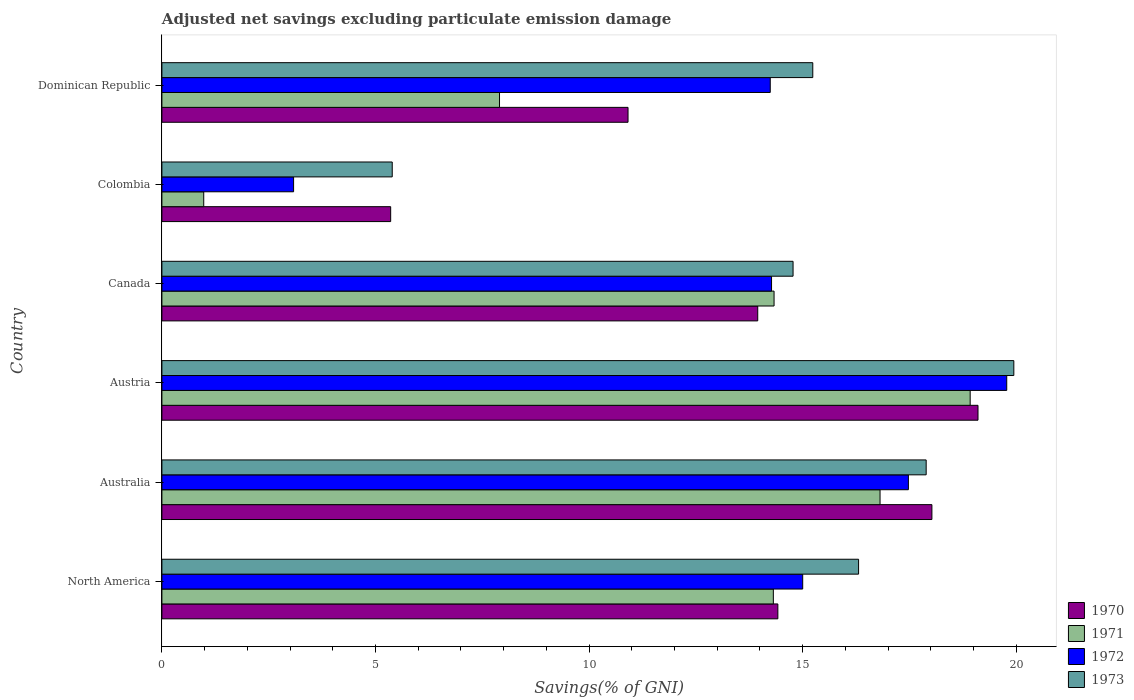How many different coloured bars are there?
Your response must be concise. 4. Are the number of bars on each tick of the Y-axis equal?
Provide a succinct answer. Yes. How many bars are there on the 4th tick from the bottom?
Your response must be concise. 4. What is the label of the 5th group of bars from the top?
Give a very brief answer. Australia. What is the adjusted net savings in 1972 in Canada?
Provide a short and direct response. 14.27. Across all countries, what is the maximum adjusted net savings in 1973?
Offer a very short reply. 19.94. Across all countries, what is the minimum adjusted net savings in 1971?
Offer a very short reply. 0.98. In which country was the adjusted net savings in 1970 maximum?
Ensure brevity in your answer.  Austria. In which country was the adjusted net savings in 1973 minimum?
Keep it short and to the point. Colombia. What is the total adjusted net savings in 1972 in the graph?
Your response must be concise. 83.85. What is the difference between the adjusted net savings in 1971 in Australia and that in Colombia?
Your response must be concise. 15.83. What is the difference between the adjusted net savings in 1971 in North America and the adjusted net savings in 1970 in Canada?
Provide a succinct answer. 0.37. What is the average adjusted net savings in 1971 per country?
Provide a short and direct response. 12.21. What is the difference between the adjusted net savings in 1970 and adjusted net savings in 1973 in Canada?
Offer a terse response. -0.83. What is the ratio of the adjusted net savings in 1970 in Austria to that in North America?
Make the answer very short. 1.32. What is the difference between the highest and the second highest adjusted net savings in 1971?
Offer a terse response. 2.11. What is the difference between the highest and the lowest adjusted net savings in 1972?
Ensure brevity in your answer.  16.7. In how many countries, is the adjusted net savings in 1970 greater than the average adjusted net savings in 1970 taken over all countries?
Your answer should be compact. 4. Is the sum of the adjusted net savings in 1971 in Australia and Canada greater than the maximum adjusted net savings in 1973 across all countries?
Provide a succinct answer. Yes. Is it the case that in every country, the sum of the adjusted net savings in 1973 and adjusted net savings in 1972 is greater than the sum of adjusted net savings in 1971 and adjusted net savings in 1970?
Provide a succinct answer. No. What does the 3rd bar from the top in North America represents?
Your answer should be compact. 1971. How many bars are there?
Your answer should be compact. 24. Are all the bars in the graph horizontal?
Give a very brief answer. Yes. How many countries are there in the graph?
Keep it short and to the point. 6. What is the difference between two consecutive major ticks on the X-axis?
Keep it short and to the point. 5. Does the graph contain any zero values?
Offer a terse response. No. How many legend labels are there?
Give a very brief answer. 4. What is the title of the graph?
Provide a succinct answer. Adjusted net savings excluding particulate emission damage. Does "1991" appear as one of the legend labels in the graph?
Give a very brief answer. No. What is the label or title of the X-axis?
Your answer should be very brief. Savings(% of GNI). What is the label or title of the Y-axis?
Provide a short and direct response. Country. What is the Savings(% of GNI) of 1970 in North America?
Keep it short and to the point. 14.42. What is the Savings(% of GNI) of 1971 in North America?
Your answer should be compact. 14.31. What is the Savings(% of GNI) of 1972 in North America?
Make the answer very short. 15. What is the Savings(% of GNI) of 1973 in North America?
Provide a succinct answer. 16.31. What is the Savings(% of GNI) in 1970 in Australia?
Your answer should be very brief. 18.03. What is the Savings(% of GNI) of 1971 in Australia?
Ensure brevity in your answer.  16.81. What is the Savings(% of GNI) of 1972 in Australia?
Provide a short and direct response. 17.48. What is the Savings(% of GNI) of 1973 in Australia?
Ensure brevity in your answer.  17.89. What is the Savings(% of GNI) in 1970 in Austria?
Give a very brief answer. 19.11. What is the Savings(% of GNI) in 1971 in Austria?
Make the answer very short. 18.92. What is the Savings(% of GNI) in 1972 in Austria?
Offer a terse response. 19.78. What is the Savings(% of GNI) of 1973 in Austria?
Provide a short and direct response. 19.94. What is the Savings(% of GNI) in 1970 in Canada?
Your answer should be very brief. 13.95. What is the Savings(% of GNI) in 1971 in Canada?
Keep it short and to the point. 14.33. What is the Savings(% of GNI) of 1972 in Canada?
Your response must be concise. 14.27. What is the Savings(% of GNI) in 1973 in Canada?
Keep it short and to the point. 14.78. What is the Savings(% of GNI) in 1970 in Colombia?
Your response must be concise. 5.36. What is the Savings(% of GNI) in 1971 in Colombia?
Your answer should be compact. 0.98. What is the Savings(% of GNI) in 1972 in Colombia?
Ensure brevity in your answer.  3.08. What is the Savings(% of GNI) of 1973 in Colombia?
Provide a succinct answer. 5.39. What is the Savings(% of GNI) of 1970 in Dominican Republic?
Your response must be concise. 10.91. What is the Savings(% of GNI) of 1971 in Dominican Republic?
Offer a very short reply. 7.9. What is the Savings(% of GNI) in 1972 in Dominican Republic?
Offer a very short reply. 14.24. What is the Savings(% of GNI) of 1973 in Dominican Republic?
Provide a short and direct response. 15.24. Across all countries, what is the maximum Savings(% of GNI) of 1970?
Provide a short and direct response. 19.11. Across all countries, what is the maximum Savings(% of GNI) of 1971?
Ensure brevity in your answer.  18.92. Across all countries, what is the maximum Savings(% of GNI) in 1972?
Make the answer very short. 19.78. Across all countries, what is the maximum Savings(% of GNI) in 1973?
Ensure brevity in your answer.  19.94. Across all countries, what is the minimum Savings(% of GNI) in 1970?
Your answer should be compact. 5.36. Across all countries, what is the minimum Savings(% of GNI) of 1971?
Give a very brief answer. 0.98. Across all countries, what is the minimum Savings(% of GNI) in 1972?
Give a very brief answer. 3.08. Across all countries, what is the minimum Savings(% of GNI) in 1973?
Your answer should be very brief. 5.39. What is the total Savings(% of GNI) of 1970 in the graph?
Provide a short and direct response. 81.77. What is the total Savings(% of GNI) of 1971 in the graph?
Make the answer very short. 73.26. What is the total Savings(% of GNI) of 1972 in the graph?
Provide a short and direct response. 83.85. What is the total Savings(% of GNI) of 1973 in the graph?
Your answer should be compact. 89.55. What is the difference between the Savings(% of GNI) in 1970 in North America and that in Australia?
Your answer should be very brief. -3.61. What is the difference between the Savings(% of GNI) of 1971 in North America and that in Australia?
Offer a terse response. -2.5. What is the difference between the Savings(% of GNI) of 1972 in North America and that in Australia?
Make the answer very short. -2.47. What is the difference between the Savings(% of GNI) in 1973 in North America and that in Australia?
Provide a short and direct response. -1.58. What is the difference between the Savings(% of GNI) in 1970 in North America and that in Austria?
Give a very brief answer. -4.69. What is the difference between the Savings(% of GNI) in 1971 in North America and that in Austria?
Your answer should be compact. -4.61. What is the difference between the Savings(% of GNI) of 1972 in North America and that in Austria?
Offer a very short reply. -4.78. What is the difference between the Savings(% of GNI) in 1973 in North America and that in Austria?
Your response must be concise. -3.63. What is the difference between the Savings(% of GNI) of 1970 in North America and that in Canada?
Your response must be concise. 0.47. What is the difference between the Savings(% of GNI) of 1971 in North America and that in Canada?
Your answer should be very brief. -0.02. What is the difference between the Savings(% of GNI) of 1972 in North America and that in Canada?
Keep it short and to the point. 0.73. What is the difference between the Savings(% of GNI) in 1973 in North America and that in Canada?
Ensure brevity in your answer.  1.53. What is the difference between the Savings(% of GNI) of 1970 in North America and that in Colombia?
Provide a short and direct response. 9.06. What is the difference between the Savings(% of GNI) in 1971 in North America and that in Colombia?
Make the answer very short. 13.34. What is the difference between the Savings(% of GNI) of 1972 in North America and that in Colombia?
Offer a terse response. 11.92. What is the difference between the Savings(% of GNI) of 1973 in North America and that in Colombia?
Your answer should be compact. 10.92. What is the difference between the Savings(% of GNI) in 1970 in North America and that in Dominican Republic?
Your answer should be very brief. 3.51. What is the difference between the Savings(% of GNI) of 1971 in North America and that in Dominican Republic?
Make the answer very short. 6.41. What is the difference between the Savings(% of GNI) in 1972 in North America and that in Dominican Republic?
Ensure brevity in your answer.  0.76. What is the difference between the Savings(% of GNI) of 1973 in North America and that in Dominican Republic?
Keep it short and to the point. 1.07. What is the difference between the Savings(% of GNI) of 1970 in Australia and that in Austria?
Your answer should be very brief. -1.08. What is the difference between the Savings(% of GNI) of 1971 in Australia and that in Austria?
Provide a succinct answer. -2.11. What is the difference between the Savings(% of GNI) of 1972 in Australia and that in Austria?
Offer a terse response. -2.3. What is the difference between the Savings(% of GNI) in 1973 in Australia and that in Austria?
Your answer should be compact. -2.05. What is the difference between the Savings(% of GNI) in 1970 in Australia and that in Canada?
Your response must be concise. 4.08. What is the difference between the Savings(% of GNI) of 1971 in Australia and that in Canada?
Offer a terse response. 2.48. What is the difference between the Savings(% of GNI) in 1972 in Australia and that in Canada?
Offer a very short reply. 3.2. What is the difference between the Savings(% of GNI) in 1973 in Australia and that in Canada?
Your answer should be very brief. 3.12. What is the difference between the Savings(% of GNI) in 1970 in Australia and that in Colombia?
Make the answer very short. 12.67. What is the difference between the Savings(% of GNI) of 1971 in Australia and that in Colombia?
Ensure brevity in your answer.  15.83. What is the difference between the Savings(% of GNI) of 1972 in Australia and that in Colombia?
Your answer should be very brief. 14.39. What is the difference between the Savings(% of GNI) in 1973 in Australia and that in Colombia?
Your response must be concise. 12.5. What is the difference between the Savings(% of GNI) of 1970 in Australia and that in Dominican Republic?
Give a very brief answer. 7.11. What is the difference between the Savings(% of GNI) in 1971 in Australia and that in Dominican Republic?
Your answer should be very brief. 8.91. What is the difference between the Savings(% of GNI) in 1972 in Australia and that in Dominican Republic?
Ensure brevity in your answer.  3.23. What is the difference between the Savings(% of GNI) of 1973 in Australia and that in Dominican Republic?
Keep it short and to the point. 2.65. What is the difference between the Savings(% of GNI) of 1970 in Austria and that in Canada?
Give a very brief answer. 5.16. What is the difference between the Savings(% of GNI) in 1971 in Austria and that in Canada?
Your response must be concise. 4.59. What is the difference between the Savings(% of GNI) of 1972 in Austria and that in Canada?
Offer a terse response. 5.51. What is the difference between the Savings(% of GNI) in 1973 in Austria and that in Canada?
Provide a succinct answer. 5.17. What is the difference between the Savings(% of GNI) of 1970 in Austria and that in Colombia?
Provide a short and direct response. 13.75. What is the difference between the Savings(% of GNI) in 1971 in Austria and that in Colombia?
Keep it short and to the point. 17.94. What is the difference between the Savings(% of GNI) of 1972 in Austria and that in Colombia?
Offer a very short reply. 16.7. What is the difference between the Savings(% of GNI) in 1973 in Austria and that in Colombia?
Offer a very short reply. 14.55. What is the difference between the Savings(% of GNI) in 1970 in Austria and that in Dominican Republic?
Your answer should be compact. 8.19. What is the difference between the Savings(% of GNI) in 1971 in Austria and that in Dominican Republic?
Give a very brief answer. 11.02. What is the difference between the Savings(% of GNI) in 1972 in Austria and that in Dominican Republic?
Ensure brevity in your answer.  5.54. What is the difference between the Savings(% of GNI) of 1973 in Austria and that in Dominican Republic?
Provide a succinct answer. 4.71. What is the difference between the Savings(% of GNI) of 1970 in Canada and that in Colombia?
Provide a succinct answer. 8.59. What is the difference between the Savings(% of GNI) in 1971 in Canada and that in Colombia?
Offer a very short reply. 13.35. What is the difference between the Savings(% of GNI) of 1972 in Canada and that in Colombia?
Your response must be concise. 11.19. What is the difference between the Savings(% of GNI) in 1973 in Canada and that in Colombia?
Provide a succinct answer. 9.38. What is the difference between the Savings(% of GNI) of 1970 in Canada and that in Dominican Republic?
Provide a succinct answer. 3.04. What is the difference between the Savings(% of GNI) in 1971 in Canada and that in Dominican Republic?
Ensure brevity in your answer.  6.43. What is the difference between the Savings(% of GNI) of 1972 in Canada and that in Dominican Republic?
Ensure brevity in your answer.  0.03. What is the difference between the Savings(% of GNI) of 1973 in Canada and that in Dominican Republic?
Provide a succinct answer. -0.46. What is the difference between the Savings(% of GNI) of 1970 in Colombia and that in Dominican Republic?
Make the answer very short. -5.56. What is the difference between the Savings(% of GNI) of 1971 in Colombia and that in Dominican Republic?
Offer a very short reply. -6.92. What is the difference between the Savings(% of GNI) in 1972 in Colombia and that in Dominican Republic?
Make the answer very short. -11.16. What is the difference between the Savings(% of GNI) in 1973 in Colombia and that in Dominican Republic?
Give a very brief answer. -9.85. What is the difference between the Savings(% of GNI) of 1970 in North America and the Savings(% of GNI) of 1971 in Australia?
Offer a terse response. -2.39. What is the difference between the Savings(% of GNI) of 1970 in North America and the Savings(% of GNI) of 1972 in Australia?
Provide a short and direct response. -3.06. What is the difference between the Savings(% of GNI) in 1970 in North America and the Savings(% of GNI) in 1973 in Australia?
Offer a very short reply. -3.47. What is the difference between the Savings(% of GNI) in 1971 in North America and the Savings(% of GNI) in 1972 in Australia?
Keep it short and to the point. -3.16. What is the difference between the Savings(% of GNI) of 1971 in North America and the Savings(% of GNI) of 1973 in Australia?
Give a very brief answer. -3.58. What is the difference between the Savings(% of GNI) of 1972 in North America and the Savings(% of GNI) of 1973 in Australia?
Give a very brief answer. -2.89. What is the difference between the Savings(% of GNI) in 1970 in North America and the Savings(% of GNI) in 1971 in Austria?
Provide a succinct answer. -4.5. What is the difference between the Savings(% of GNI) in 1970 in North America and the Savings(% of GNI) in 1972 in Austria?
Your answer should be compact. -5.36. What is the difference between the Savings(% of GNI) in 1970 in North America and the Savings(% of GNI) in 1973 in Austria?
Offer a terse response. -5.52. What is the difference between the Savings(% of GNI) in 1971 in North America and the Savings(% of GNI) in 1972 in Austria?
Provide a succinct answer. -5.46. What is the difference between the Savings(% of GNI) in 1971 in North America and the Savings(% of GNI) in 1973 in Austria?
Offer a very short reply. -5.63. What is the difference between the Savings(% of GNI) of 1972 in North America and the Savings(% of GNI) of 1973 in Austria?
Provide a succinct answer. -4.94. What is the difference between the Savings(% of GNI) of 1970 in North America and the Savings(% of GNI) of 1971 in Canada?
Provide a succinct answer. 0.09. What is the difference between the Savings(% of GNI) of 1970 in North America and the Savings(% of GNI) of 1972 in Canada?
Make the answer very short. 0.15. What is the difference between the Savings(% of GNI) in 1970 in North America and the Savings(% of GNI) in 1973 in Canada?
Keep it short and to the point. -0.36. What is the difference between the Savings(% of GNI) of 1971 in North America and the Savings(% of GNI) of 1972 in Canada?
Keep it short and to the point. 0.04. What is the difference between the Savings(% of GNI) of 1971 in North America and the Savings(% of GNI) of 1973 in Canada?
Offer a very short reply. -0.46. What is the difference between the Savings(% of GNI) of 1972 in North America and the Savings(% of GNI) of 1973 in Canada?
Keep it short and to the point. 0.23. What is the difference between the Savings(% of GNI) in 1970 in North America and the Savings(% of GNI) in 1971 in Colombia?
Ensure brevity in your answer.  13.44. What is the difference between the Savings(% of GNI) in 1970 in North America and the Savings(% of GNI) in 1972 in Colombia?
Your answer should be very brief. 11.34. What is the difference between the Savings(% of GNI) of 1970 in North America and the Savings(% of GNI) of 1973 in Colombia?
Your answer should be very brief. 9.03. What is the difference between the Savings(% of GNI) in 1971 in North America and the Savings(% of GNI) in 1972 in Colombia?
Provide a succinct answer. 11.23. What is the difference between the Savings(% of GNI) of 1971 in North America and the Savings(% of GNI) of 1973 in Colombia?
Provide a short and direct response. 8.92. What is the difference between the Savings(% of GNI) of 1972 in North America and the Savings(% of GNI) of 1973 in Colombia?
Your answer should be very brief. 9.61. What is the difference between the Savings(% of GNI) of 1970 in North America and the Savings(% of GNI) of 1971 in Dominican Republic?
Your answer should be very brief. 6.52. What is the difference between the Savings(% of GNI) of 1970 in North America and the Savings(% of GNI) of 1972 in Dominican Republic?
Offer a very short reply. 0.18. What is the difference between the Savings(% of GNI) of 1970 in North America and the Savings(% of GNI) of 1973 in Dominican Republic?
Your response must be concise. -0.82. What is the difference between the Savings(% of GNI) in 1971 in North America and the Savings(% of GNI) in 1972 in Dominican Republic?
Give a very brief answer. 0.07. What is the difference between the Savings(% of GNI) in 1971 in North America and the Savings(% of GNI) in 1973 in Dominican Republic?
Provide a short and direct response. -0.92. What is the difference between the Savings(% of GNI) in 1972 in North America and the Savings(% of GNI) in 1973 in Dominican Republic?
Your answer should be compact. -0.24. What is the difference between the Savings(% of GNI) in 1970 in Australia and the Savings(% of GNI) in 1971 in Austria?
Provide a succinct answer. -0.9. What is the difference between the Savings(% of GNI) in 1970 in Australia and the Savings(% of GNI) in 1972 in Austria?
Your response must be concise. -1.75. What is the difference between the Savings(% of GNI) in 1970 in Australia and the Savings(% of GNI) in 1973 in Austria?
Your response must be concise. -1.92. What is the difference between the Savings(% of GNI) in 1971 in Australia and the Savings(% of GNI) in 1972 in Austria?
Your response must be concise. -2.97. What is the difference between the Savings(% of GNI) of 1971 in Australia and the Savings(% of GNI) of 1973 in Austria?
Keep it short and to the point. -3.13. What is the difference between the Savings(% of GNI) of 1972 in Australia and the Savings(% of GNI) of 1973 in Austria?
Offer a very short reply. -2.47. What is the difference between the Savings(% of GNI) in 1970 in Australia and the Savings(% of GNI) in 1971 in Canada?
Offer a very short reply. 3.7. What is the difference between the Savings(% of GNI) of 1970 in Australia and the Savings(% of GNI) of 1972 in Canada?
Your answer should be very brief. 3.75. What is the difference between the Savings(% of GNI) of 1970 in Australia and the Savings(% of GNI) of 1973 in Canada?
Your answer should be very brief. 3.25. What is the difference between the Savings(% of GNI) in 1971 in Australia and the Savings(% of GNI) in 1972 in Canada?
Your answer should be compact. 2.54. What is the difference between the Savings(% of GNI) in 1971 in Australia and the Savings(% of GNI) in 1973 in Canada?
Your answer should be very brief. 2.04. What is the difference between the Savings(% of GNI) of 1972 in Australia and the Savings(% of GNI) of 1973 in Canada?
Give a very brief answer. 2.7. What is the difference between the Savings(% of GNI) of 1970 in Australia and the Savings(% of GNI) of 1971 in Colombia?
Give a very brief answer. 17.05. What is the difference between the Savings(% of GNI) in 1970 in Australia and the Savings(% of GNI) in 1972 in Colombia?
Ensure brevity in your answer.  14.94. What is the difference between the Savings(% of GNI) in 1970 in Australia and the Savings(% of GNI) in 1973 in Colombia?
Your answer should be compact. 12.63. What is the difference between the Savings(% of GNI) of 1971 in Australia and the Savings(% of GNI) of 1972 in Colombia?
Make the answer very short. 13.73. What is the difference between the Savings(% of GNI) in 1971 in Australia and the Savings(% of GNI) in 1973 in Colombia?
Offer a terse response. 11.42. What is the difference between the Savings(% of GNI) of 1972 in Australia and the Savings(% of GNI) of 1973 in Colombia?
Provide a short and direct response. 12.08. What is the difference between the Savings(% of GNI) of 1970 in Australia and the Savings(% of GNI) of 1971 in Dominican Republic?
Ensure brevity in your answer.  10.12. What is the difference between the Savings(% of GNI) of 1970 in Australia and the Savings(% of GNI) of 1972 in Dominican Republic?
Your answer should be very brief. 3.78. What is the difference between the Savings(% of GNI) of 1970 in Australia and the Savings(% of GNI) of 1973 in Dominican Republic?
Ensure brevity in your answer.  2.79. What is the difference between the Savings(% of GNI) of 1971 in Australia and the Savings(% of GNI) of 1972 in Dominican Republic?
Keep it short and to the point. 2.57. What is the difference between the Savings(% of GNI) of 1971 in Australia and the Savings(% of GNI) of 1973 in Dominican Republic?
Your answer should be very brief. 1.57. What is the difference between the Savings(% of GNI) in 1972 in Australia and the Savings(% of GNI) in 1973 in Dominican Republic?
Keep it short and to the point. 2.24. What is the difference between the Savings(% of GNI) in 1970 in Austria and the Savings(% of GNI) in 1971 in Canada?
Ensure brevity in your answer.  4.77. What is the difference between the Savings(% of GNI) of 1970 in Austria and the Savings(% of GNI) of 1972 in Canada?
Make the answer very short. 4.83. What is the difference between the Savings(% of GNI) of 1970 in Austria and the Savings(% of GNI) of 1973 in Canada?
Provide a succinct answer. 4.33. What is the difference between the Savings(% of GNI) in 1971 in Austria and the Savings(% of GNI) in 1972 in Canada?
Your answer should be very brief. 4.65. What is the difference between the Savings(% of GNI) of 1971 in Austria and the Savings(% of GNI) of 1973 in Canada?
Your answer should be compact. 4.15. What is the difference between the Savings(% of GNI) of 1972 in Austria and the Savings(% of GNI) of 1973 in Canada?
Your answer should be compact. 5. What is the difference between the Savings(% of GNI) in 1970 in Austria and the Savings(% of GNI) in 1971 in Colombia?
Your answer should be very brief. 18.13. What is the difference between the Savings(% of GNI) of 1970 in Austria and the Savings(% of GNI) of 1972 in Colombia?
Ensure brevity in your answer.  16.02. What is the difference between the Savings(% of GNI) in 1970 in Austria and the Savings(% of GNI) in 1973 in Colombia?
Your answer should be very brief. 13.71. What is the difference between the Savings(% of GNI) in 1971 in Austria and the Savings(% of GNI) in 1972 in Colombia?
Keep it short and to the point. 15.84. What is the difference between the Savings(% of GNI) of 1971 in Austria and the Savings(% of GNI) of 1973 in Colombia?
Your answer should be compact. 13.53. What is the difference between the Savings(% of GNI) of 1972 in Austria and the Savings(% of GNI) of 1973 in Colombia?
Offer a very short reply. 14.39. What is the difference between the Savings(% of GNI) of 1970 in Austria and the Savings(% of GNI) of 1971 in Dominican Republic?
Your answer should be compact. 11.2. What is the difference between the Savings(% of GNI) of 1970 in Austria and the Savings(% of GNI) of 1972 in Dominican Republic?
Make the answer very short. 4.86. What is the difference between the Savings(% of GNI) in 1970 in Austria and the Savings(% of GNI) in 1973 in Dominican Republic?
Your answer should be very brief. 3.87. What is the difference between the Savings(% of GNI) in 1971 in Austria and the Savings(% of GNI) in 1972 in Dominican Republic?
Ensure brevity in your answer.  4.68. What is the difference between the Savings(% of GNI) in 1971 in Austria and the Savings(% of GNI) in 1973 in Dominican Republic?
Provide a succinct answer. 3.68. What is the difference between the Savings(% of GNI) in 1972 in Austria and the Savings(% of GNI) in 1973 in Dominican Republic?
Provide a short and direct response. 4.54. What is the difference between the Savings(% of GNI) of 1970 in Canada and the Savings(% of GNI) of 1971 in Colombia?
Offer a very short reply. 12.97. What is the difference between the Savings(% of GNI) in 1970 in Canada and the Savings(% of GNI) in 1972 in Colombia?
Your response must be concise. 10.87. What is the difference between the Savings(% of GNI) of 1970 in Canada and the Savings(% of GNI) of 1973 in Colombia?
Offer a very short reply. 8.56. What is the difference between the Savings(% of GNI) of 1971 in Canada and the Savings(% of GNI) of 1972 in Colombia?
Your answer should be compact. 11.25. What is the difference between the Savings(% of GNI) of 1971 in Canada and the Savings(% of GNI) of 1973 in Colombia?
Your answer should be very brief. 8.94. What is the difference between the Savings(% of GNI) in 1972 in Canada and the Savings(% of GNI) in 1973 in Colombia?
Keep it short and to the point. 8.88. What is the difference between the Savings(% of GNI) in 1970 in Canada and the Savings(% of GNI) in 1971 in Dominican Republic?
Your answer should be very brief. 6.05. What is the difference between the Savings(% of GNI) of 1970 in Canada and the Savings(% of GNI) of 1972 in Dominican Republic?
Give a very brief answer. -0.29. What is the difference between the Savings(% of GNI) in 1970 in Canada and the Savings(% of GNI) in 1973 in Dominican Republic?
Keep it short and to the point. -1.29. What is the difference between the Savings(% of GNI) of 1971 in Canada and the Savings(% of GNI) of 1972 in Dominican Republic?
Ensure brevity in your answer.  0.09. What is the difference between the Savings(% of GNI) of 1971 in Canada and the Savings(% of GNI) of 1973 in Dominican Republic?
Your answer should be compact. -0.91. What is the difference between the Savings(% of GNI) of 1972 in Canada and the Savings(% of GNI) of 1973 in Dominican Republic?
Your response must be concise. -0.97. What is the difference between the Savings(% of GNI) of 1970 in Colombia and the Savings(% of GNI) of 1971 in Dominican Republic?
Your answer should be compact. -2.55. What is the difference between the Savings(% of GNI) in 1970 in Colombia and the Savings(% of GNI) in 1972 in Dominican Republic?
Your response must be concise. -8.89. What is the difference between the Savings(% of GNI) of 1970 in Colombia and the Savings(% of GNI) of 1973 in Dominican Republic?
Give a very brief answer. -9.88. What is the difference between the Savings(% of GNI) in 1971 in Colombia and the Savings(% of GNI) in 1972 in Dominican Republic?
Your response must be concise. -13.26. What is the difference between the Savings(% of GNI) of 1971 in Colombia and the Savings(% of GNI) of 1973 in Dominican Republic?
Your answer should be very brief. -14.26. What is the difference between the Savings(% of GNI) in 1972 in Colombia and the Savings(% of GNI) in 1973 in Dominican Republic?
Your response must be concise. -12.15. What is the average Savings(% of GNI) of 1970 per country?
Offer a terse response. 13.63. What is the average Savings(% of GNI) of 1971 per country?
Your response must be concise. 12.21. What is the average Savings(% of GNI) of 1972 per country?
Ensure brevity in your answer.  13.98. What is the average Savings(% of GNI) of 1973 per country?
Offer a very short reply. 14.93. What is the difference between the Savings(% of GNI) of 1970 and Savings(% of GNI) of 1971 in North America?
Keep it short and to the point. 0.11. What is the difference between the Savings(% of GNI) in 1970 and Savings(% of GNI) in 1972 in North America?
Offer a very short reply. -0.58. What is the difference between the Savings(% of GNI) in 1970 and Savings(% of GNI) in 1973 in North America?
Offer a terse response. -1.89. What is the difference between the Savings(% of GNI) in 1971 and Savings(% of GNI) in 1972 in North America?
Keep it short and to the point. -0.69. What is the difference between the Savings(% of GNI) of 1971 and Savings(% of GNI) of 1973 in North America?
Offer a terse response. -2. What is the difference between the Savings(% of GNI) of 1972 and Savings(% of GNI) of 1973 in North America?
Provide a succinct answer. -1.31. What is the difference between the Savings(% of GNI) of 1970 and Savings(% of GNI) of 1971 in Australia?
Ensure brevity in your answer.  1.21. What is the difference between the Savings(% of GNI) of 1970 and Savings(% of GNI) of 1972 in Australia?
Your answer should be compact. 0.55. What is the difference between the Savings(% of GNI) of 1970 and Savings(% of GNI) of 1973 in Australia?
Provide a short and direct response. 0.13. What is the difference between the Savings(% of GNI) in 1971 and Savings(% of GNI) in 1972 in Australia?
Provide a succinct answer. -0.66. What is the difference between the Savings(% of GNI) of 1971 and Savings(% of GNI) of 1973 in Australia?
Offer a terse response. -1.08. What is the difference between the Savings(% of GNI) of 1972 and Savings(% of GNI) of 1973 in Australia?
Ensure brevity in your answer.  -0.42. What is the difference between the Savings(% of GNI) in 1970 and Savings(% of GNI) in 1971 in Austria?
Your answer should be very brief. 0.18. What is the difference between the Savings(% of GNI) in 1970 and Savings(% of GNI) in 1972 in Austria?
Provide a short and direct response. -0.67. What is the difference between the Savings(% of GNI) of 1970 and Savings(% of GNI) of 1973 in Austria?
Your answer should be compact. -0.84. What is the difference between the Savings(% of GNI) of 1971 and Savings(% of GNI) of 1972 in Austria?
Offer a terse response. -0.86. What is the difference between the Savings(% of GNI) of 1971 and Savings(% of GNI) of 1973 in Austria?
Offer a very short reply. -1.02. What is the difference between the Savings(% of GNI) in 1972 and Savings(% of GNI) in 1973 in Austria?
Provide a short and direct response. -0.17. What is the difference between the Savings(% of GNI) of 1970 and Savings(% of GNI) of 1971 in Canada?
Your answer should be compact. -0.38. What is the difference between the Savings(% of GNI) of 1970 and Savings(% of GNI) of 1972 in Canada?
Provide a short and direct response. -0.32. What is the difference between the Savings(% of GNI) in 1970 and Savings(% of GNI) in 1973 in Canada?
Your response must be concise. -0.83. What is the difference between the Savings(% of GNI) in 1971 and Savings(% of GNI) in 1972 in Canada?
Offer a terse response. 0.06. What is the difference between the Savings(% of GNI) of 1971 and Savings(% of GNI) of 1973 in Canada?
Ensure brevity in your answer.  -0.45. What is the difference between the Savings(% of GNI) in 1972 and Savings(% of GNI) in 1973 in Canada?
Give a very brief answer. -0.5. What is the difference between the Savings(% of GNI) of 1970 and Savings(% of GNI) of 1971 in Colombia?
Ensure brevity in your answer.  4.38. What is the difference between the Savings(% of GNI) of 1970 and Savings(% of GNI) of 1972 in Colombia?
Ensure brevity in your answer.  2.27. What is the difference between the Savings(% of GNI) in 1970 and Savings(% of GNI) in 1973 in Colombia?
Keep it short and to the point. -0.04. What is the difference between the Savings(% of GNI) of 1971 and Savings(% of GNI) of 1972 in Colombia?
Your response must be concise. -2.1. What is the difference between the Savings(% of GNI) in 1971 and Savings(% of GNI) in 1973 in Colombia?
Your answer should be compact. -4.41. What is the difference between the Savings(% of GNI) of 1972 and Savings(% of GNI) of 1973 in Colombia?
Your answer should be very brief. -2.31. What is the difference between the Savings(% of GNI) of 1970 and Savings(% of GNI) of 1971 in Dominican Republic?
Your response must be concise. 3.01. What is the difference between the Savings(% of GNI) in 1970 and Savings(% of GNI) in 1972 in Dominican Republic?
Ensure brevity in your answer.  -3.33. What is the difference between the Savings(% of GNI) of 1970 and Savings(% of GNI) of 1973 in Dominican Republic?
Provide a short and direct response. -4.33. What is the difference between the Savings(% of GNI) in 1971 and Savings(% of GNI) in 1972 in Dominican Republic?
Provide a succinct answer. -6.34. What is the difference between the Savings(% of GNI) of 1971 and Savings(% of GNI) of 1973 in Dominican Republic?
Provide a succinct answer. -7.33. What is the difference between the Savings(% of GNI) in 1972 and Savings(% of GNI) in 1973 in Dominican Republic?
Make the answer very short. -1. What is the ratio of the Savings(% of GNI) in 1970 in North America to that in Australia?
Your response must be concise. 0.8. What is the ratio of the Savings(% of GNI) of 1971 in North America to that in Australia?
Give a very brief answer. 0.85. What is the ratio of the Savings(% of GNI) of 1972 in North America to that in Australia?
Keep it short and to the point. 0.86. What is the ratio of the Savings(% of GNI) of 1973 in North America to that in Australia?
Your answer should be very brief. 0.91. What is the ratio of the Savings(% of GNI) in 1970 in North America to that in Austria?
Make the answer very short. 0.75. What is the ratio of the Savings(% of GNI) of 1971 in North America to that in Austria?
Your response must be concise. 0.76. What is the ratio of the Savings(% of GNI) of 1972 in North America to that in Austria?
Your answer should be very brief. 0.76. What is the ratio of the Savings(% of GNI) of 1973 in North America to that in Austria?
Make the answer very short. 0.82. What is the ratio of the Savings(% of GNI) of 1970 in North America to that in Canada?
Provide a short and direct response. 1.03. What is the ratio of the Savings(% of GNI) in 1972 in North America to that in Canada?
Provide a succinct answer. 1.05. What is the ratio of the Savings(% of GNI) in 1973 in North America to that in Canada?
Keep it short and to the point. 1.1. What is the ratio of the Savings(% of GNI) in 1970 in North America to that in Colombia?
Give a very brief answer. 2.69. What is the ratio of the Savings(% of GNI) in 1971 in North America to that in Colombia?
Provide a succinct answer. 14.62. What is the ratio of the Savings(% of GNI) of 1972 in North America to that in Colombia?
Your answer should be compact. 4.87. What is the ratio of the Savings(% of GNI) of 1973 in North America to that in Colombia?
Keep it short and to the point. 3.02. What is the ratio of the Savings(% of GNI) in 1970 in North America to that in Dominican Republic?
Keep it short and to the point. 1.32. What is the ratio of the Savings(% of GNI) of 1971 in North America to that in Dominican Republic?
Your answer should be compact. 1.81. What is the ratio of the Savings(% of GNI) of 1972 in North America to that in Dominican Republic?
Offer a very short reply. 1.05. What is the ratio of the Savings(% of GNI) in 1973 in North America to that in Dominican Republic?
Offer a terse response. 1.07. What is the ratio of the Savings(% of GNI) of 1970 in Australia to that in Austria?
Provide a succinct answer. 0.94. What is the ratio of the Savings(% of GNI) in 1971 in Australia to that in Austria?
Your answer should be very brief. 0.89. What is the ratio of the Savings(% of GNI) in 1972 in Australia to that in Austria?
Your answer should be compact. 0.88. What is the ratio of the Savings(% of GNI) in 1973 in Australia to that in Austria?
Provide a short and direct response. 0.9. What is the ratio of the Savings(% of GNI) in 1970 in Australia to that in Canada?
Ensure brevity in your answer.  1.29. What is the ratio of the Savings(% of GNI) in 1971 in Australia to that in Canada?
Make the answer very short. 1.17. What is the ratio of the Savings(% of GNI) of 1972 in Australia to that in Canada?
Provide a short and direct response. 1.22. What is the ratio of the Savings(% of GNI) of 1973 in Australia to that in Canada?
Your answer should be compact. 1.21. What is the ratio of the Savings(% of GNI) in 1970 in Australia to that in Colombia?
Offer a very short reply. 3.37. What is the ratio of the Savings(% of GNI) in 1971 in Australia to that in Colombia?
Make the answer very short. 17.17. What is the ratio of the Savings(% of GNI) of 1972 in Australia to that in Colombia?
Offer a very short reply. 5.67. What is the ratio of the Savings(% of GNI) of 1973 in Australia to that in Colombia?
Ensure brevity in your answer.  3.32. What is the ratio of the Savings(% of GNI) in 1970 in Australia to that in Dominican Republic?
Give a very brief answer. 1.65. What is the ratio of the Savings(% of GNI) of 1971 in Australia to that in Dominican Republic?
Ensure brevity in your answer.  2.13. What is the ratio of the Savings(% of GNI) in 1972 in Australia to that in Dominican Republic?
Offer a terse response. 1.23. What is the ratio of the Savings(% of GNI) of 1973 in Australia to that in Dominican Republic?
Your answer should be compact. 1.17. What is the ratio of the Savings(% of GNI) of 1970 in Austria to that in Canada?
Provide a short and direct response. 1.37. What is the ratio of the Savings(% of GNI) of 1971 in Austria to that in Canada?
Give a very brief answer. 1.32. What is the ratio of the Savings(% of GNI) of 1972 in Austria to that in Canada?
Your answer should be very brief. 1.39. What is the ratio of the Savings(% of GNI) of 1973 in Austria to that in Canada?
Provide a succinct answer. 1.35. What is the ratio of the Savings(% of GNI) of 1970 in Austria to that in Colombia?
Ensure brevity in your answer.  3.57. What is the ratio of the Savings(% of GNI) in 1971 in Austria to that in Colombia?
Offer a terse response. 19.32. What is the ratio of the Savings(% of GNI) in 1972 in Austria to that in Colombia?
Ensure brevity in your answer.  6.42. What is the ratio of the Savings(% of GNI) of 1973 in Austria to that in Colombia?
Provide a succinct answer. 3.7. What is the ratio of the Savings(% of GNI) in 1970 in Austria to that in Dominican Republic?
Ensure brevity in your answer.  1.75. What is the ratio of the Savings(% of GNI) of 1971 in Austria to that in Dominican Republic?
Give a very brief answer. 2.39. What is the ratio of the Savings(% of GNI) of 1972 in Austria to that in Dominican Republic?
Offer a terse response. 1.39. What is the ratio of the Savings(% of GNI) of 1973 in Austria to that in Dominican Republic?
Your answer should be very brief. 1.31. What is the ratio of the Savings(% of GNI) in 1970 in Canada to that in Colombia?
Provide a short and direct response. 2.6. What is the ratio of the Savings(% of GNI) in 1971 in Canada to that in Colombia?
Offer a very short reply. 14.64. What is the ratio of the Savings(% of GNI) in 1972 in Canada to that in Colombia?
Make the answer very short. 4.63. What is the ratio of the Savings(% of GNI) in 1973 in Canada to that in Colombia?
Your response must be concise. 2.74. What is the ratio of the Savings(% of GNI) of 1970 in Canada to that in Dominican Republic?
Give a very brief answer. 1.28. What is the ratio of the Savings(% of GNI) of 1971 in Canada to that in Dominican Republic?
Give a very brief answer. 1.81. What is the ratio of the Savings(% of GNI) of 1973 in Canada to that in Dominican Republic?
Your answer should be compact. 0.97. What is the ratio of the Savings(% of GNI) in 1970 in Colombia to that in Dominican Republic?
Give a very brief answer. 0.49. What is the ratio of the Savings(% of GNI) in 1971 in Colombia to that in Dominican Republic?
Your answer should be very brief. 0.12. What is the ratio of the Savings(% of GNI) of 1972 in Colombia to that in Dominican Republic?
Keep it short and to the point. 0.22. What is the ratio of the Savings(% of GNI) in 1973 in Colombia to that in Dominican Republic?
Offer a very short reply. 0.35. What is the difference between the highest and the second highest Savings(% of GNI) in 1970?
Make the answer very short. 1.08. What is the difference between the highest and the second highest Savings(% of GNI) of 1971?
Offer a terse response. 2.11. What is the difference between the highest and the second highest Savings(% of GNI) in 1972?
Provide a short and direct response. 2.3. What is the difference between the highest and the second highest Savings(% of GNI) in 1973?
Offer a very short reply. 2.05. What is the difference between the highest and the lowest Savings(% of GNI) in 1970?
Your response must be concise. 13.75. What is the difference between the highest and the lowest Savings(% of GNI) in 1971?
Offer a very short reply. 17.94. What is the difference between the highest and the lowest Savings(% of GNI) in 1972?
Your response must be concise. 16.7. What is the difference between the highest and the lowest Savings(% of GNI) in 1973?
Ensure brevity in your answer.  14.55. 